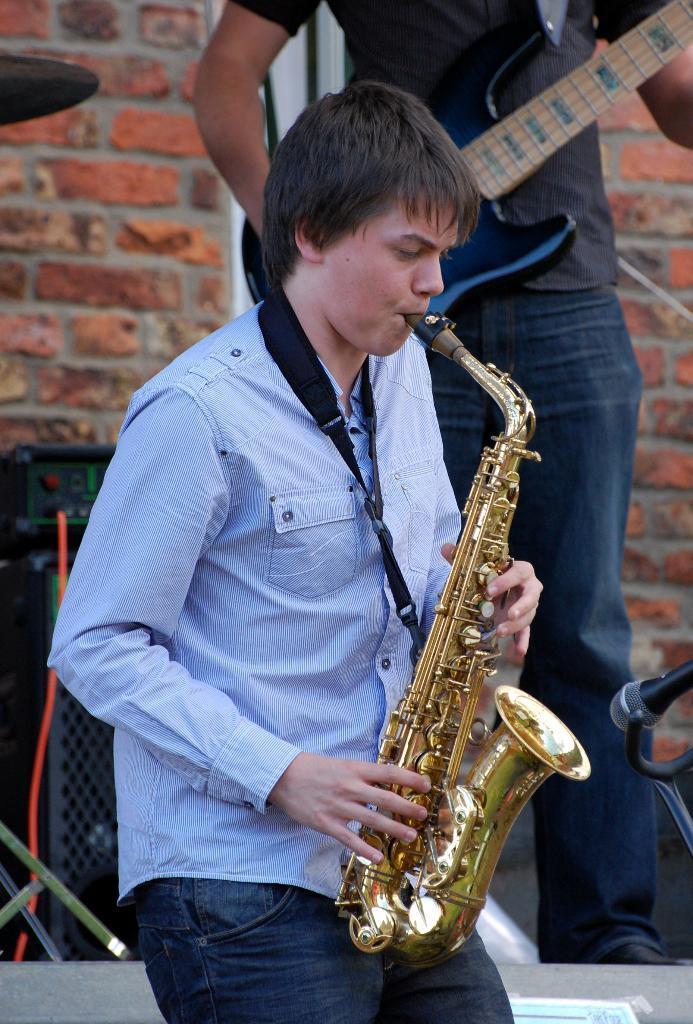Could you give a brief overview of what you see in this image? A man is playing a saxophone. 